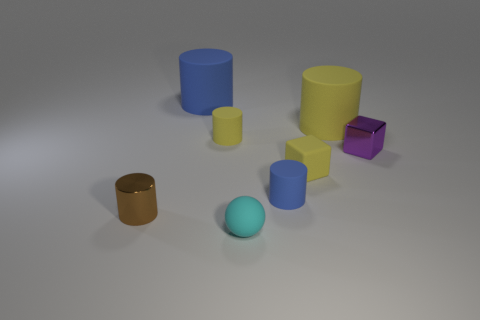What is the size of the blue cylinder that is made of the same material as the small blue thing?
Make the answer very short. Large. What number of blue matte objects are in front of the matte cylinder in front of the tiny metal cube?
Make the answer very short. 0. Is there a big rubber thing that has the same shape as the tiny blue rubber object?
Offer a terse response. Yes. There is a tiny shiny thing that is behind the object to the left of the large blue object; what is its color?
Offer a very short reply. Purple. Is the number of purple metal things greater than the number of rubber things?
Offer a very short reply. No. How many blue cylinders are the same size as the cyan object?
Your answer should be compact. 1. Are the sphere and the small object that is on the right side of the large yellow thing made of the same material?
Your answer should be compact. No. Are there fewer small shiny things than brown objects?
Provide a short and direct response. No. Is there anything else of the same color as the tiny matte cube?
Make the answer very short. Yes. There is a small brown thing that is made of the same material as the tiny purple thing; what shape is it?
Keep it short and to the point. Cylinder. 